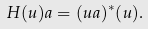<formula> <loc_0><loc_0><loc_500><loc_500>H ( u ) a = ( u a ) ^ { * } ( u ) .</formula> 